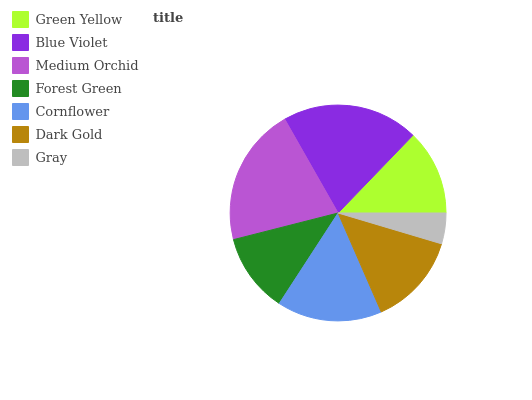Is Gray the minimum?
Answer yes or no. Yes. Is Medium Orchid the maximum?
Answer yes or no. Yes. Is Blue Violet the minimum?
Answer yes or no. No. Is Blue Violet the maximum?
Answer yes or no. No. Is Blue Violet greater than Green Yellow?
Answer yes or no. Yes. Is Green Yellow less than Blue Violet?
Answer yes or no. Yes. Is Green Yellow greater than Blue Violet?
Answer yes or no. No. Is Blue Violet less than Green Yellow?
Answer yes or no. No. Is Dark Gold the high median?
Answer yes or no. Yes. Is Dark Gold the low median?
Answer yes or no. Yes. Is Medium Orchid the high median?
Answer yes or no. No. Is Green Yellow the low median?
Answer yes or no. No. 